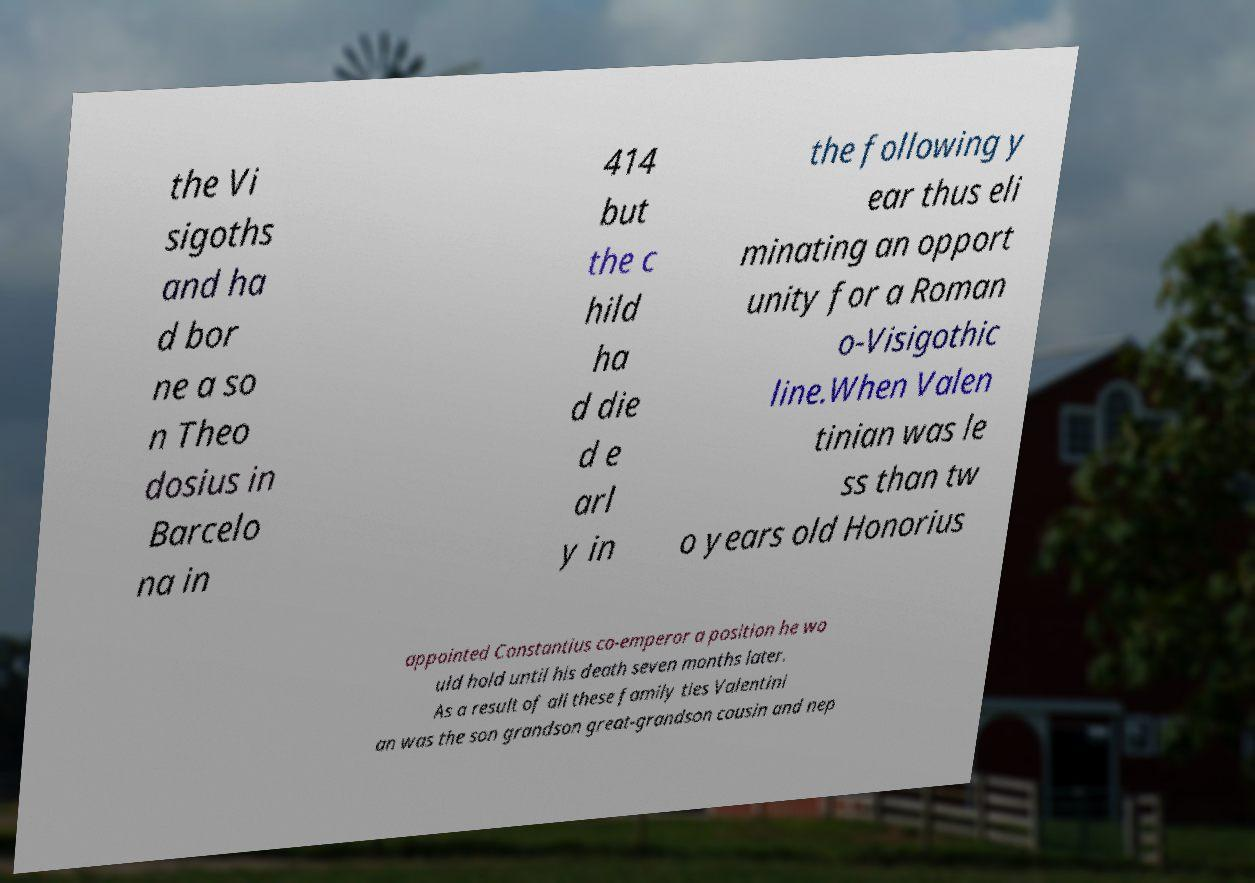Please read and relay the text visible in this image. What does it say? the Vi sigoths and ha d bor ne a so n Theo dosius in Barcelo na in 414 but the c hild ha d die d e arl y in the following y ear thus eli minating an opport unity for a Roman o-Visigothic line.When Valen tinian was le ss than tw o years old Honorius appointed Constantius co-emperor a position he wo uld hold until his death seven months later. As a result of all these family ties Valentini an was the son grandson great-grandson cousin and nep 